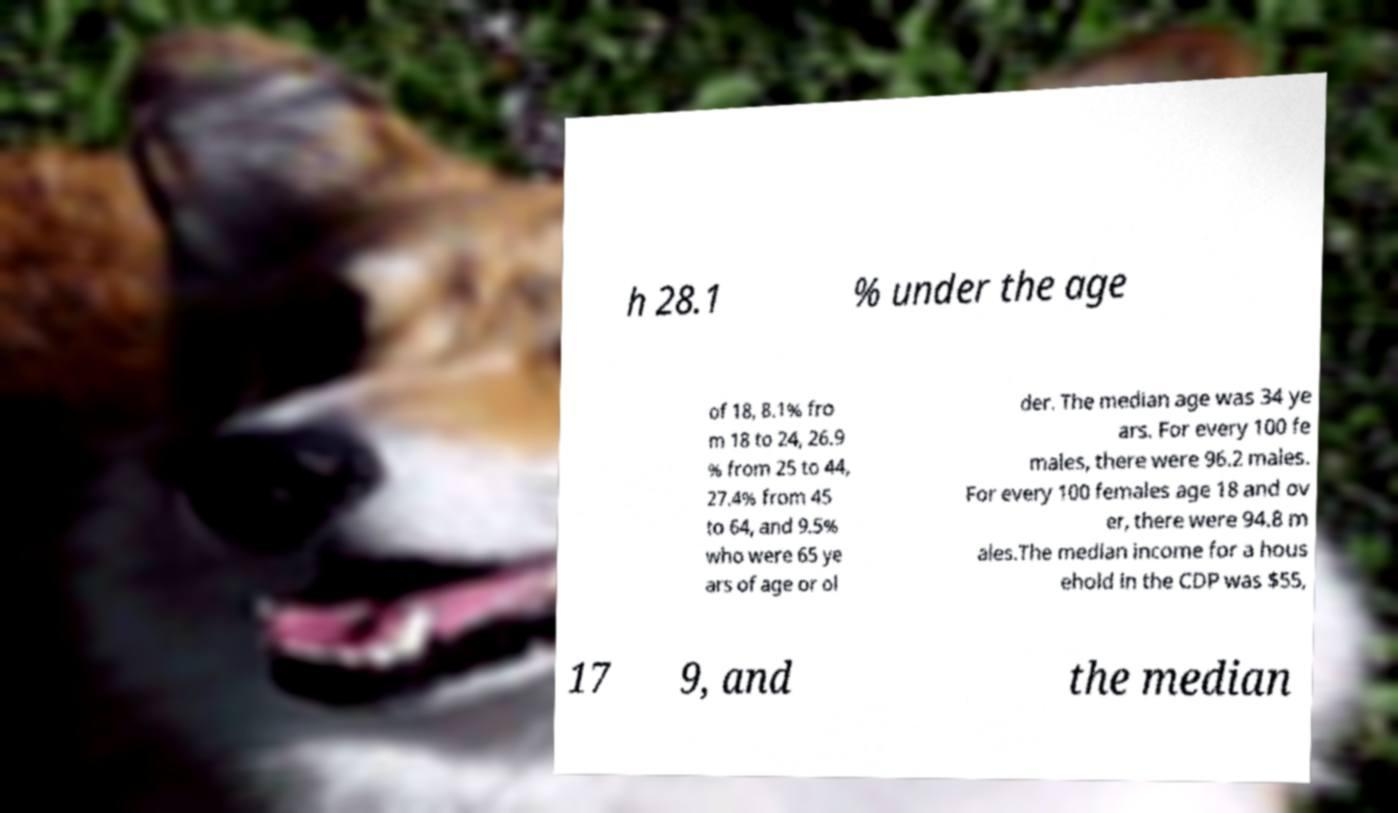Can you read and provide the text displayed in the image?This photo seems to have some interesting text. Can you extract and type it out for me? h 28.1 % under the age of 18, 8.1% fro m 18 to 24, 26.9 % from 25 to 44, 27.4% from 45 to 64, and 9.5% who were 65 ye ars of age or ol der. The median age was 34 ye ars. For every 100 fe males, there were 96.2 males. For every 100 females age 18 and ov er, there were 94.8 m ales.The median income for a hous ehold in the CDP was $55, 17 9, and the median 